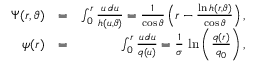Convert formula to latex. <formula><loc_0><loc_0><loc_500><loc_500>\begin{array} { r l r } { \Psi ( r , \vartheta ) } & { = } & { \int _ { 0 } ^ { r } \frac { u \, d u } { h ( u , \vartheta ) } = \frac { 1 } { \cos { \vartheta } } \left ( r - \frac { \ln h ( r , \vartheta ) } { \cos \vartheta } \right ) , } \\ { \psi ( r ) } & { = } & { \int _ { 0 } ^ { r } \frac { u \, d u } { q ( u ) } = \frac { 1 } { \sigma } \, \ln \left ( \frac { q ( r ) } { q _ { 0 } } \right ) , } \end{array}</formula> 